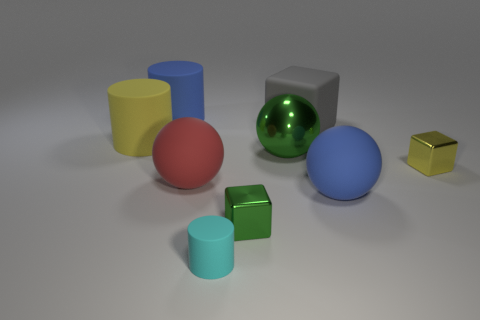Add 1 small balls. How many objects exist? 10 Subtract all cylinders. How many objects are left? 6 Subtract all tiny green shiny cylinders. Subtract all small cylinders. How many objects are left? 8 Add 5 rubber balls. How many rubber balls are left? 7 Add 9 gray blocks. How many gray blocks exist? 10 Subtract 1 green spheres. How many objects are left? 8 